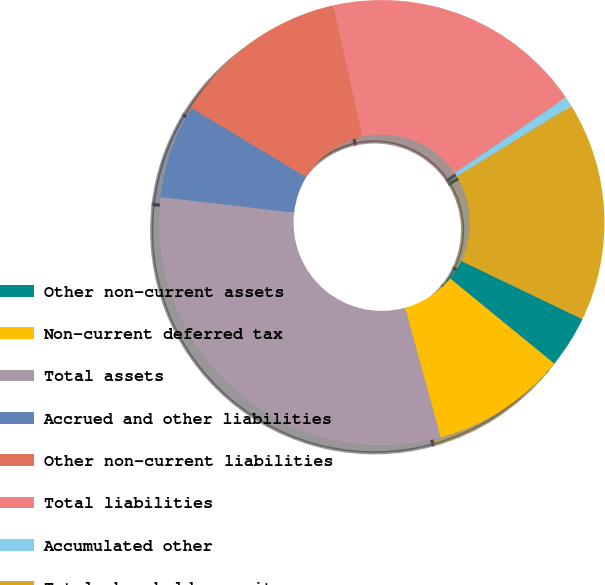Convert chart to OTSL. <chart><loc_0><loc_0><loc_500><loc_500><pie_chart><fcel>Other non-current assets<fcel>Non-current deferred tax<fcel>Total assets<fcel>Accrued and other liabilities<fcel>Other non-current liabilities<fcel>Total liabilities<fcel>Accumulated other<fcel>Total shareholder equity<nl><fcel>3.77%<fcel>9.84%<fcel>31.09%<fcel>6.8%<fcel>12.87%<fcel>18.98%<fcel>0.73%<fcel>15.91%<nl></chart> 